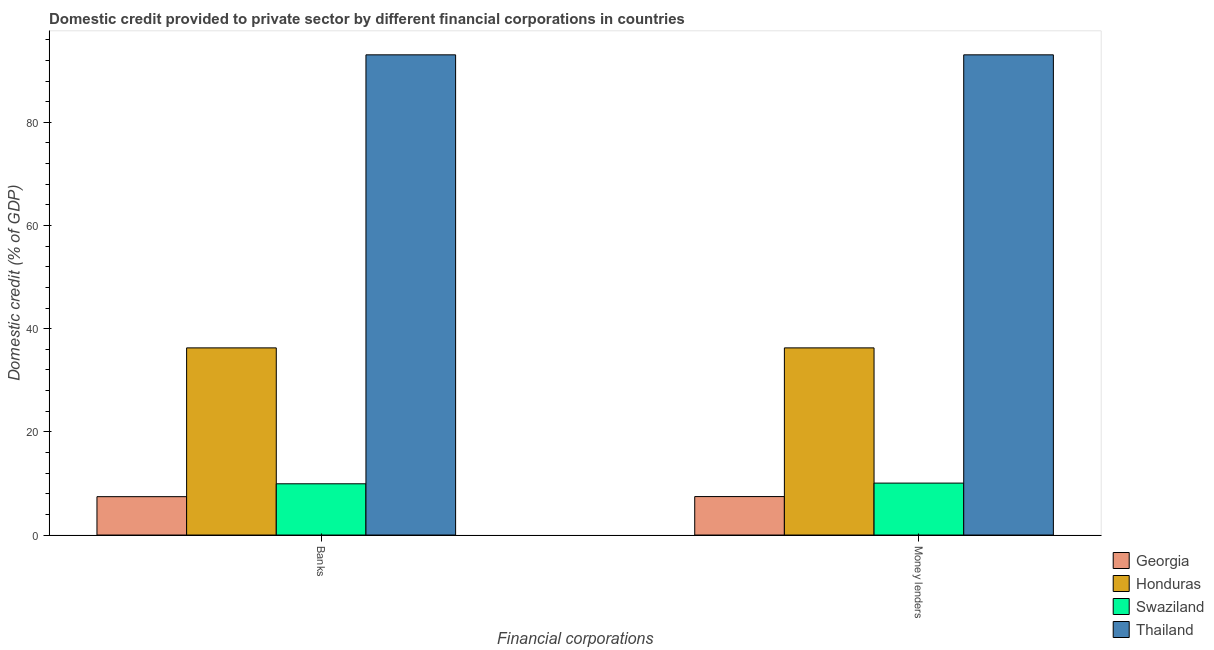Are the number of bars on each tick of the X-axis equal?
Offer a very short reply. Yes. How many bars are there on the 1st tick from the left?
Provide a short and direct response. 4. What is the label of the 2nd group of bars from the left?
Offer a terse response. Money lenders. What is the domestic credit provided by money lenders in Thailand?
Provide a short and direct response. 93.08. Across all countries, what is the maximum domestic credit provided by money lenders?
Your response must be concise. 93.08. Across all countries, what is the minimum domestic credit provided by banks?
Give a very brief answer. 7.44. In which country was the domestic credit provided by banks maximum?
Offer a terse response. Thailand. In which country was the domestic credit provided by banks minimum?
Provide a succinct answer. Georgia. What is the total domestic credit provided by money lenders in the graph?
Your answer should be compact. 146.88. What is the difference between the domestic credit provided by money lenders in Honduras and that in Swaziland?
Your answer should be compact. 26.21. What is the difference between the domestic credit provided by money lenders in Georgia and the domestic credit provided by banks in Thailand?
Your answer should be compact. -85.62. What is the average domestic credit provided by banks per country?
Provide a succinct answer. 36.68. What is the difference between the domestic credit provided by money lenders and domestic credit provided by banks in Swaziland?
Provide a succinct answer. 0.13. In how many countries, is the domestic credit provided by money lenders greater than 52 %?
Your answer should be very brief. 1. What is the ratio of the domestic credit provided by money lenders in Honduras to that in Georgia?
Offer a terse response. 4.87. In how many countries, is the domestic credit provided by banks greater than the average domestic credit provided by banks taken over all countries?
Your response must be concise. 1. What does the 4th bar from the left in Money lenders represents?
Keep it short and to the point. Thailand. What does the 3rd bar from the right in Money lenders represents?
Provide a succinct answer. Honduras. Are all the bars in the graph horizontal?
Ensure brevity in your answer.  No. Are the values on the major ticks of Y-axis written in scientific E-notation?
Your answer should be compact. No. How many legend labels are there?
Your response must be concise. 4. What is the title of the graph?
Make the answer very short. Domestic credit provided to private sector by different financial corporations in countries. Does "Iran" appear as one of the legend labels in the graph?
Keep it short and to the point. No. What is the label or title of the X-axis?
Make the answer very short. Financial corporations. What is the label or title of the Y-axis?
Provide a succinct answer. Domestic credit (% of GDP). What is the Domestic credit (% of GDP) of Georgia in Banks?
Make the answer very short. 7.44. What is the Domestic credit (% of GDP) in Honduras in Banks?
Provide a succinct answer. 36.28. What is the Domestic credit (% of GDP) in Swaziland in Banks?
Provide a succinct answer. 9.93. What is the Domestic credit (% of GDP) of Thailand in Banks?
Your response must be concise. 93.08. What is the Domestic credit (% of GDP) in Georgia in Money lenders?
Offer a very short reply. 7.45. What is the Domestic credit (% of GDP) in Honduras in Money lenders?
Offer a terse response. 36.28. What is the Domestic credit (% of GDP) in Swaziland in Money lenders?
Offer a terse response. 10.07. What is the Domestic credit (% of GDP) of Thailand in Money lenders?
Offer a terse response. 93.08. Across all Financial corporations, what is the maximum Domestic credit (% of GDP) of Georgia?
Your answer should be very brief. 7.45. Across all Financial corporations, what is the maximum Domestic credit (% of GDP) of Honduras?
Your answer should be compact. 36.28. Across all Financial corporations, what is the maximum Domestic credit (% of GDP) in Swaziland?
Your response must be concise. 10.07. Across all Financial corporations, what is the maximum Domestic credit (% of GDP) of Thailand?
Offer a very short reply. 93.08. Across all Financial corporations, what is the minimum Domestic credit (% of GDP) of Georgia?
Your answer should be compact. 7.44. Across all Financial corporations, what is the minimum Domestic credit (% of GDP) of Honduras?
Ensure brevity in your answer.  36.28. Across all Financial corporations, what is the minimum Domestic credit (% of GDP) in Swaziland?
Provide a short and direct response. 9.93. Across all Financial corporations, what is the minimum Domestic credit (% of GDP) in Thailand?
Offer a terse response. 93.08. What is the total Domestic credit (% of GDP) of Georgia in the graph?
Your answer should be very brief. 14.89. What is the total Domestic credit (% of GDP) in Honduras in the graph?
Ensure brevity in your answer.  72.55. What is the total Domestic credit (% of GDP) of Swaziland in the graph?
Provide a short and direct response. 20. What is the total Domestic credit (% of GDP) in Thailand in the graph?
Ensure brevity in your answer.  186.16. What is the difference between the Domestic credit (% of GDP) in Georgia in Banks and that in Money lenders?
Provide a succinct answer. -0.02. What is the difference between the Domestic credit (% of GDP) of Honduras in Banks and that in Money lenders?
Your answer should be compact. -0. What is the difference between the Domestic credit (% of GDP) in Swaziland in Banks and that in Money lenders?
Keep it short and to the point. -0.13. What is the difference between the Domestic credit (% of GDP) in Thailand in Banks and that in Money lenders?
Your response must be concise. 0. What is the difference between the Domestic credit (% of GDP) in Georgia in Banks and the Domestic credit (% of GDP) in Honduras in Money lenders?
Keep it short and to the point. -28.84. What is the difference between the Domestic credit (% of GDP) of Georgia in Banks and the Domestic credit (% of GDP) of Swaziland in Money lenders?
Offer a very short reply. -2.63. What is the difference between the Domestic credit (% of GDP) of Georgia in Banks and the Domestic credit (% of GDP) of Thailand in Money lenders?
Your answer should be compact. -85.64. What is the difference between the Domestic credit (% of GDP) of Honduras in Banks and the Domestic credit (% of GDP) of Swaziland in Money lenders?
Ensure brevity in your answer.  26.21. What is the difference between the Domestic credit (% of GDP) of Honduras in Banks and the Domestic credit (% of GDP) of Thailand in Money lenders?
Ensure brevity in your answer.  -56.8. What is the difference between the Domestic credit (% of GDP) in Swaziland in Banks and the Domestic credit (% of GDP) in Thailand in Money lenders?
Your answer should be compact. -83.15. What is the average Domestic credit (% of GDP) of Georgia per Financial corporations?
Give a very brief answer. 7.45. What is the average Domestic credit (% of GDP) in Honduras per Financial corporations?
Give a very brief answer. 36.28. What is the average Domestic credit (% of GDP) of Swaziland per Financial corporations?
Offer a terse response. 10. What is the average Domestic credit (% of GDP) in Thailand per Financial corporations?
Provide a succinct answer. 93.08. What is the difference between the Domestic credit (% of GDP) in Georgia and Domestic credit (% of GDP) in Honduras in Banks?
Your answer should be very brief. -28.84. What is the difference between the Domestic credit (% of GDP) in Georgia and Domestic credit (% of GDP) in Swaziland in Banks?
Your answer should be very brief. -2.5. What is the difference between the Domestic credit (% of GDP) of Georgia and Domestic credit (% of GDP) of Thailand in Banks?
Your answer should be very brief. -85.64. What is the difference between the Domestic credit (% of GDP) of Honduras and Domestic credit (% of GDP) of Swaziland in Banks?
Your answer should be compact. 26.34. What is the difference between the Domestic credit (% of GDP) in Honduras and Domestic credit (% of GDP) in Thailand in Banks?
Make the answer very short. -56.8. What is the difference between the Domestic credit (% of GDP) of Swaziland and Domestic credit (% of GDP) of Thailand in Banks?
Offer a very short reply. -83.15. What is the difference between the Domestic credit (% of GDP) in Georgia and Domestic credit (% of GDP) in Honduras in Money lenders?
Your answer should be very brief. -28.82. What is the difference between the Domestic credit (% of GDP) in Georgia and Domestic credit (% of GDP) in Swaziland in Money lenders?
Provide a succinct answer. -2.61. What is the difference between the Domestic credit (% of GDP) in Georgia and Domestic credit (% of GDP) in Thailand in Money lenders?
Offer a very short reply. -85.62. What is the difference between the Domestic credit (% of GDP) in Honduras and Domestic credit (% of GDP) in Swaziland in Money lenders?
Your answer should be compact. 26.21. What is the difference between the Domestic credit (% of GDP) of Honduras and Domestic credit (% of GDP) of Thailand in Money lenders?
Make the answer very short. -56.8. What is the difference between the Domestic credit (% of GDP) of Swaziland and Domestic credit (% of GDP) of Thailand in Money lenders?
Keep it short and to the point. -83.01. What is the ratio of the Domestic credit (% of GDP) of Swaziland in Banks to that in Money lenders?
Provide a succinct answer. 0.99. What is the ratio of the Domestic credit (% of GDP) of Thailand in Banks to that in Money lenders?
Your response must be concise. 1. What is the difference between the highest and the second highest Domestic credit (% of GDP) of Georgia?
Ensure brevity in your answer.  0.02. What is the difference between the highest and the second highest Domestic credit (% of GDP) of Honduras?
Your response must be concise. 0. What is the difference between the highest and the second highest Domestic credit (% of GDP) in Swaziland?
Your response must be concise. 0.13. What is the difference between the highest and the lowest Domestic credit (% of GDP) in Georgia?
Provide a succinct answer. 0.02. What is the difference between the highest and the lowest Domestic credit (% of GDP) of Swaziland?
Offer a terse response. 0.13. What is the difference between the highest and the lowest Domestic credit (% of GDP) of Thailand?
Give a very brief answer. 0. 